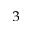<formula> <loc_0><loc_0><loc_500><loc_500>_ { 3 }</formula> 